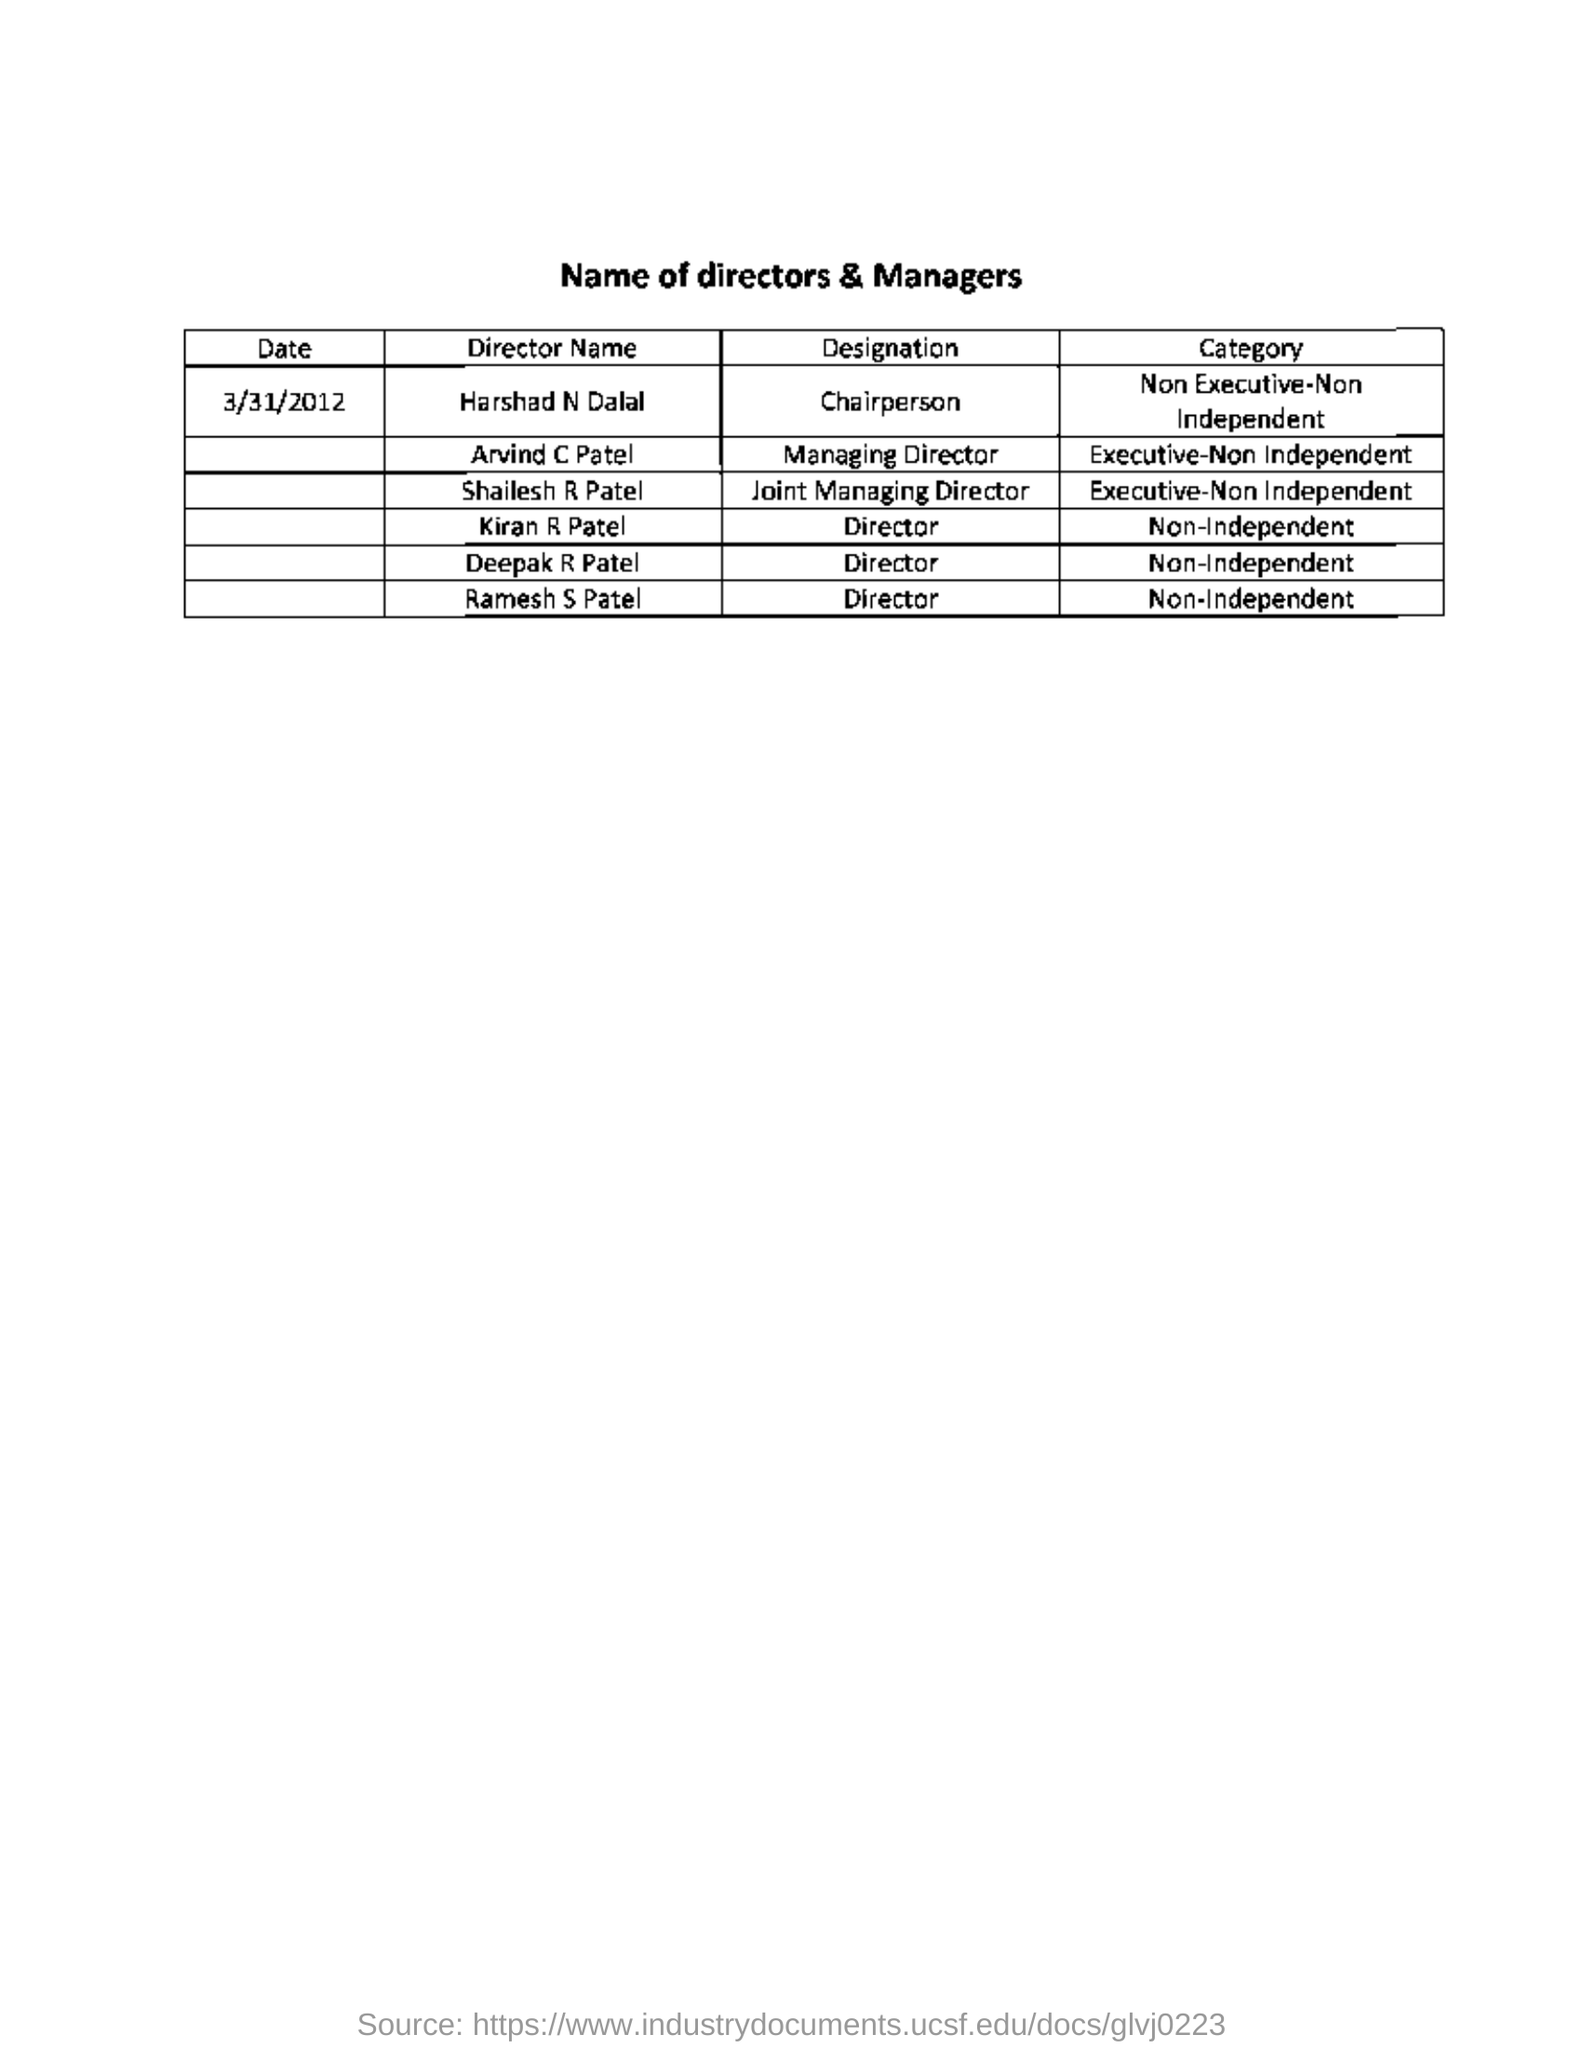What is the date mentioned in this document?
Your answer should be very brief. 3/31/2012. What is the designation of Arvind C Patel?
Give a very brief answer. Managing Director. In which category, Harshad N Dalal belongs to?
Your answer should be very brief. Non Executive-Non Independent. What is the designation of ramesh s patel for non - independent category ?
Provide a succinct answer. Director. 